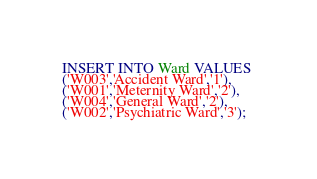<code> <loc_0><loc_0><loc_500><loc_500><_SQL_>INSERT INTO Ward VALUES 
('W003','Accident Ward','1'),
('W001','Meternity Ward','2'),
('W004','General Ward','2'),
('W002','Psychiatric Ward','3');</code> 